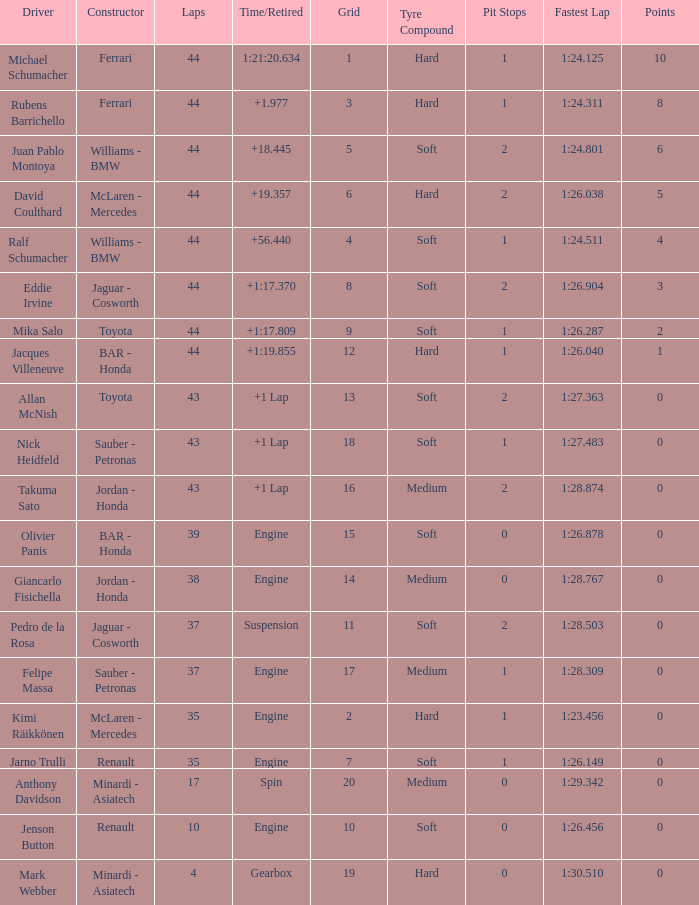What was the time of the driver on grid 3? 1.977. 